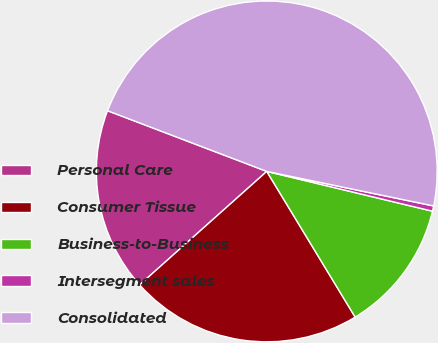Convert chart. <chart><loc_0><loc_0><loc_500><loc_500><pie_chart><fcel>Personal Care<fcel>Consumer Tissue<fcel>Business-to-Business<fcel>Intersegment sales<fcel>Consolidated<nl><fcel>17.39%<fcel>22.08%<fcel>12.57%<fcel>0.5%<fcel>47.45%<nl></chart> 